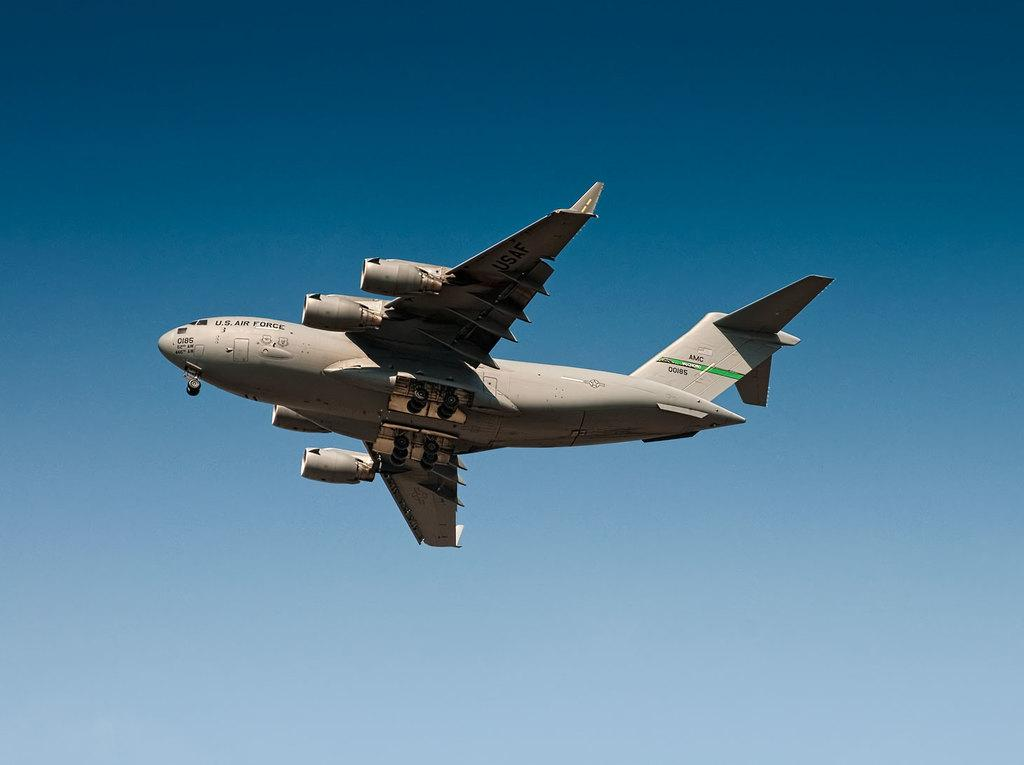What is happening in the sky in the image? There is a flight visible in the air. What else can be seen in the sky in the image? The sky is visible in the image, but no other specific details are mentioned. What type of agreement is being signed in the tent in the image? There is no tent or agreement present in the image; it only features a flight visible in the air and the sky. 